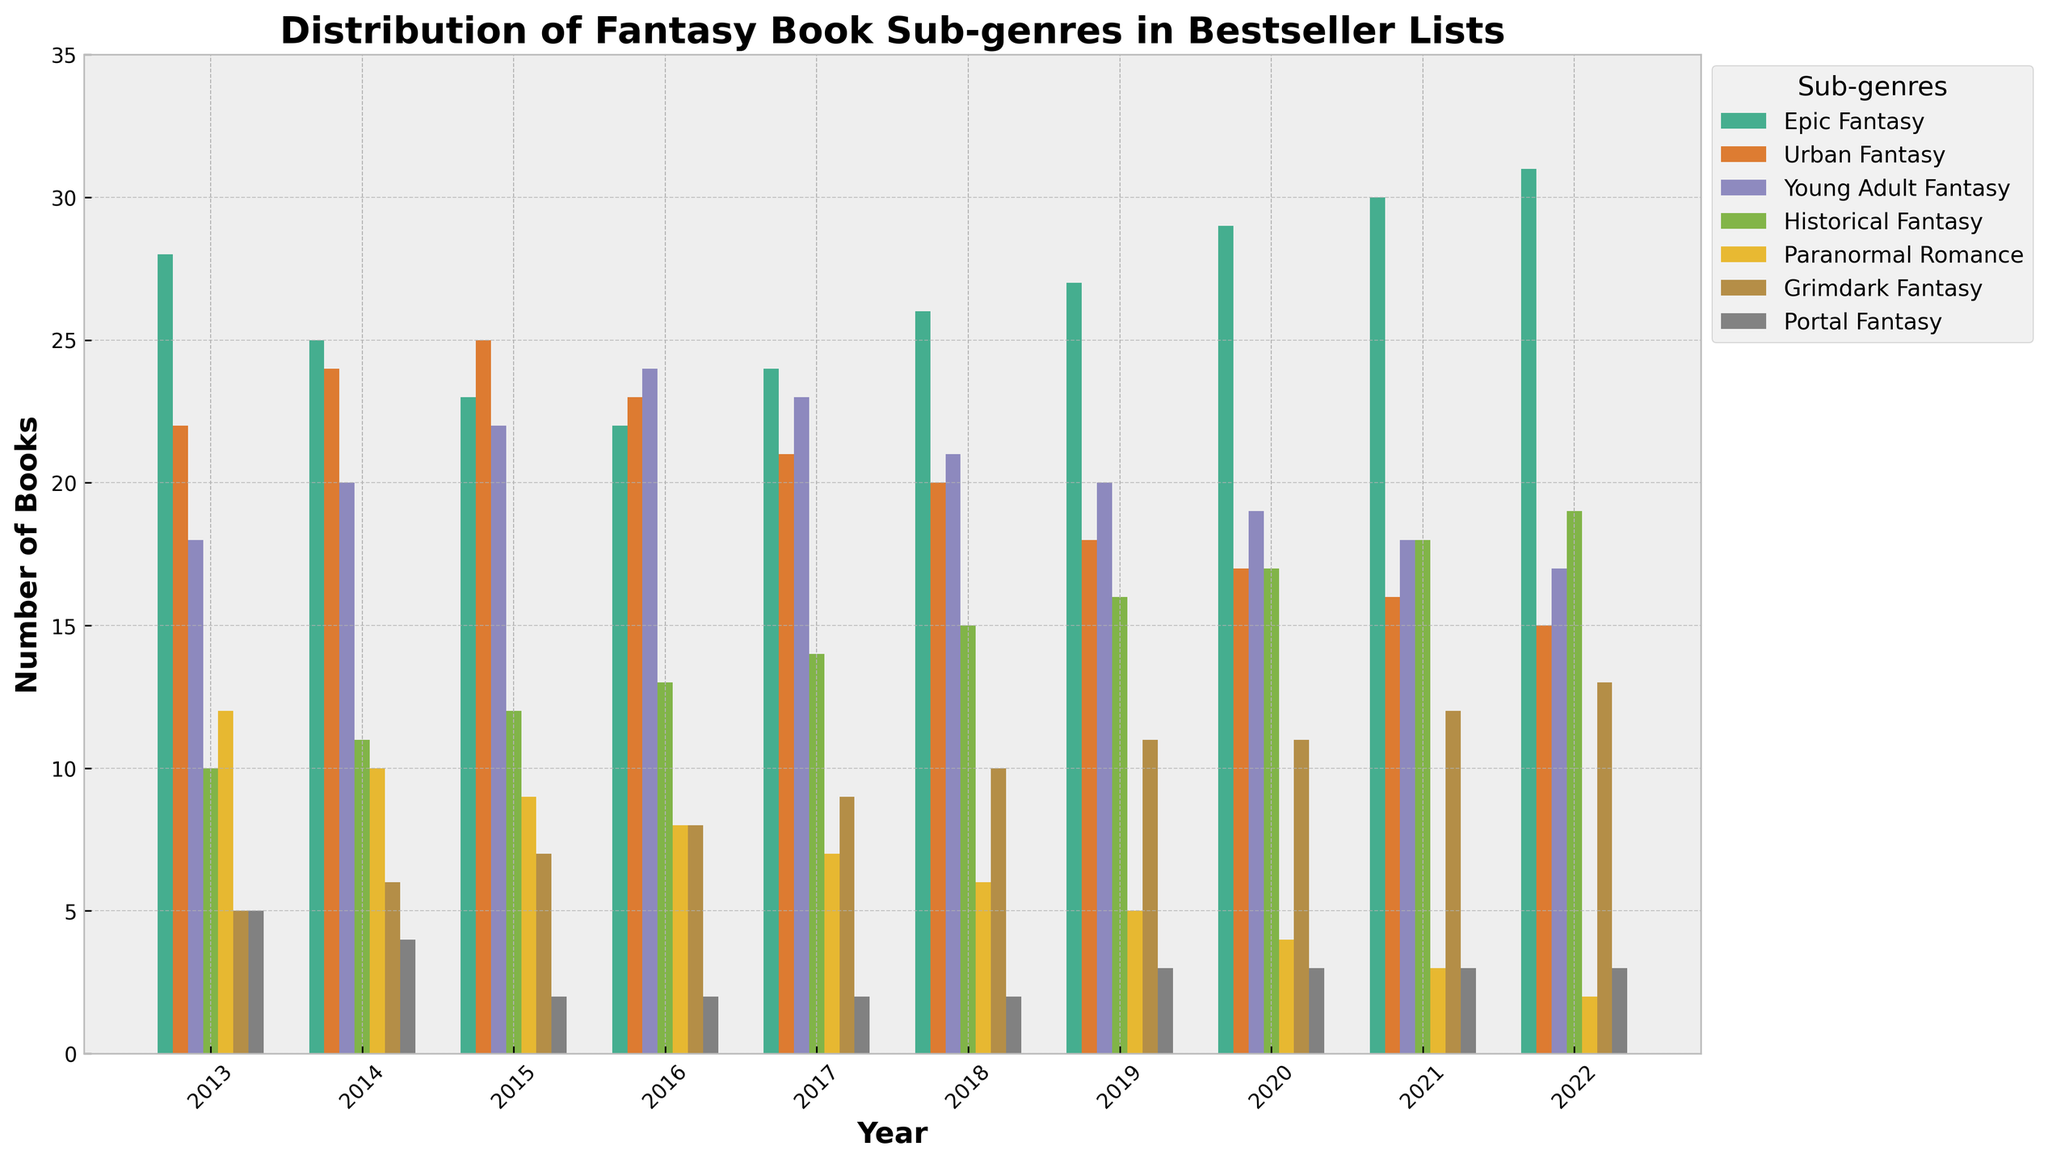Which sub-genre had the highest number of books in the year 2020? Look at the bars for the year 2020 and compare their heights. The highest bar corresponds to "Epic Fantasy".
Answer: Epic Fantasy Which sub-genre consistently increased in numbers from 2013 to 2022? Observe the trend of each sub-genre by following the height of the bars across the years 2013 to 2022. "Historical Fantasy" shows a consistent increase.
Answer: Historical Fantasy In which year did Urban Fantasy have the most books in the bestseller list? Check the bars representing Urban Fantasy for the highest value year. The year with the highest bar for Urban Fantasy is 2015.
Answer: 2015 What is the total number of Young Adult Fantasy books from 2013 to 2022? Sum the values of Young Adult Fantasy for each year from 2013 to 2022: 18+20+22+24+23+21+20+19+18+17. The total is 202.
Answer: 202 How many more Epic Fantasy books were there than Grimdark Fantasy books in 2022? Subtract the number of Grimdark Fantasy books from the number of Epic Fantasy books for the year 2022: 31 - 13. The result is 18.
Answer: 18 Which sub-genre has the most noticeable decline over the years? Identify the sub-genre with the most significant decrease in numbers by comparing the differences in heights over the years. Paranormal Romance shows a clear decline.
Answer: Paranormal Romance What is the average number of Portal Fantasy books in the bestseller lists over the depicted decade? Calculate the average by summing all values for Portal Fantasy from 2013 to 2022 and then dividing by the number of years: (5 + 4 + 2 + 2 + 2 + 2 + 3 + 3 + 3 + 3)/10 = 2.9.
Answer: 2.9 In which year did Grimdark Fantasy surpass Urban Fantasy in the number of books for the first time? Compare yearly values of Grimdark Fantasy against Urban Fantasy. Grimdark Fantasy surpassed Urban Fantasy for the first time in 2022.
Answer: 2022 Which sub-genre had the most steady number of books in the bestsellers' lists from 2013 to 2022? Identify the sub-genre with the least variation in bar heights. Portal Fantasy remains the most stable, with a slight change.
Answer: Portal Fantasy What is the difference in the total number of Urban Fantasy and Paranormal Romance books over the entire decade? Summing the values for all years for Urban Fantasy and Paranormal Romance and then finding the difference: (22 + 24 + 25 + 23 + 21 + 20 + 18 + 17 + 16 + 15) - (12 + 10 + 9 + 8 + 7 + 6 + 5 + 4 + 3 + 2) = 201 - 66 = 135.
Answer: 135 